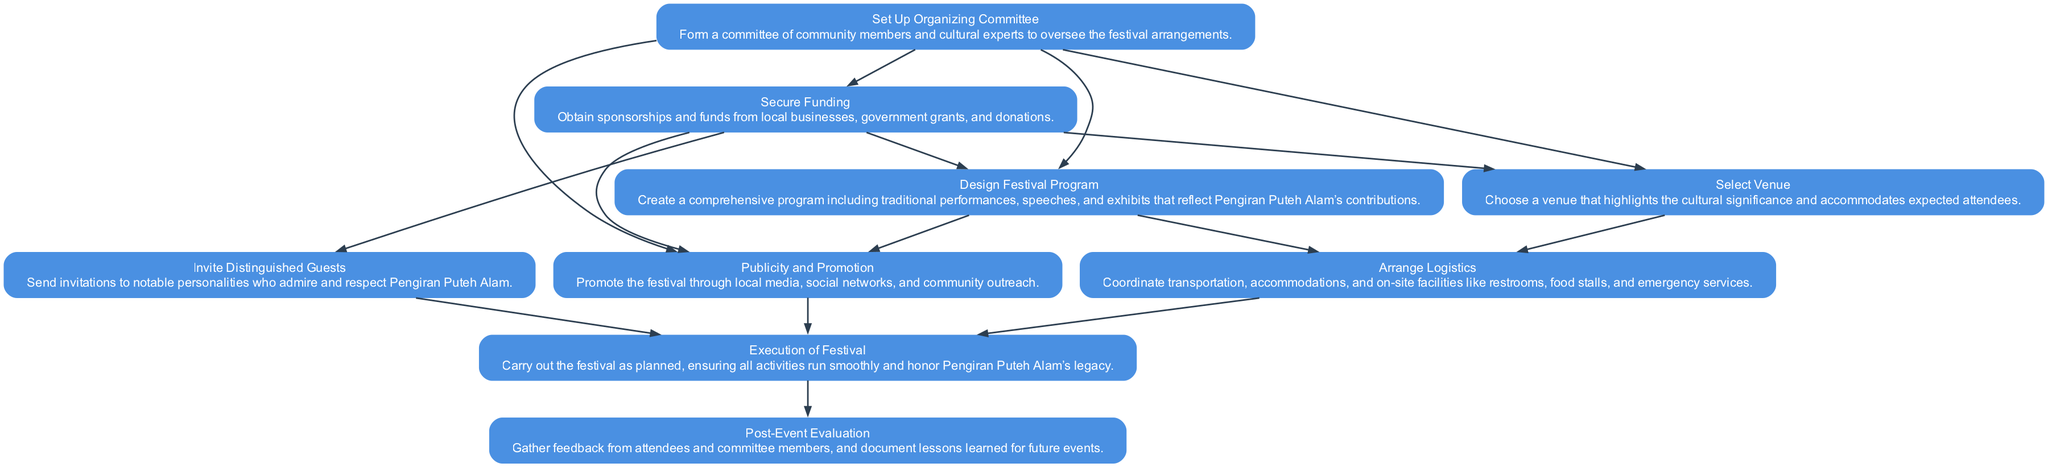What is the first step in organizing the festival? The first step in organizing the festival, as indicated in the diagram, is "Set Up Organizing Committee." There are no dependencies for this step, making it the starting point.
Answer: Set Up Organizing Committee How many nodes are in the diagram? By counting each unique step or event in the flow chart, we find there are nine distinct nodes listed, each representing a task or process in organizing the cultural festival.
Answer: Nine Which step follows "Secure Funding"? According to the diagram, the steps that directly follow "Secure Funding" are "Select Venue" and "Invite Distinguished Guests." Both are dependent on securing funding.
Answer: Select Venue, Invite Distinguished Guests What task must be completed before "Execution of Festival"? The tasks that must be completed before "Execution of Festival," as shown in the diagram, are "Arrange Logistics," "Invite Distinguished Guests," and "Publicity and Promotion." All these steps need to be finalized prior to the festival's execution.
Answer: Arrange Logistics, Invite Distinguished Guests, Publicity and Promotion What is the purpose of the "Post-Event Evaluation"? The purpose of "Post-Event Evaluation" is to gather feedback from attendees and committee members and to document lessons learned for future events. This reflective step helps improve future festival organization.
Answer: Gather feedback and document lessons learned What is the relationship between "Design Festival Program" and "Publicity and Promotion"? The relationship between the two tasks is that "Publicity and Promotion" is dependent on "Design Festival Program." This indicates that the promotional activities can only commence after the festival program is fully designed and established.
Answer: Publicity and Promotion depends on Design Festival Program How many dependencies does "Arrange Logistics" have? The "Arrange Logistics" task has two dependencies: "Select Venue" and "Design Festival Program." Both must be completed before logistics can be arranged for the festival.
Answer: Two Name one source of funding mentioned in the diagram. The diagram mentions "sponsorships" as one source of funding, along with local businesses, government grants, and donations. This highlights the importance of community and business involvement in financing the festival.
Answer: Sponsorships What comes after "Set Up Organizing Committee" in the flow? After "Set Up Organizing Committee," the next steps in the flow are "Secure Funding," which is the first task that requires the committee's formation for effective planning and execution.
Answer: Secure Funding 